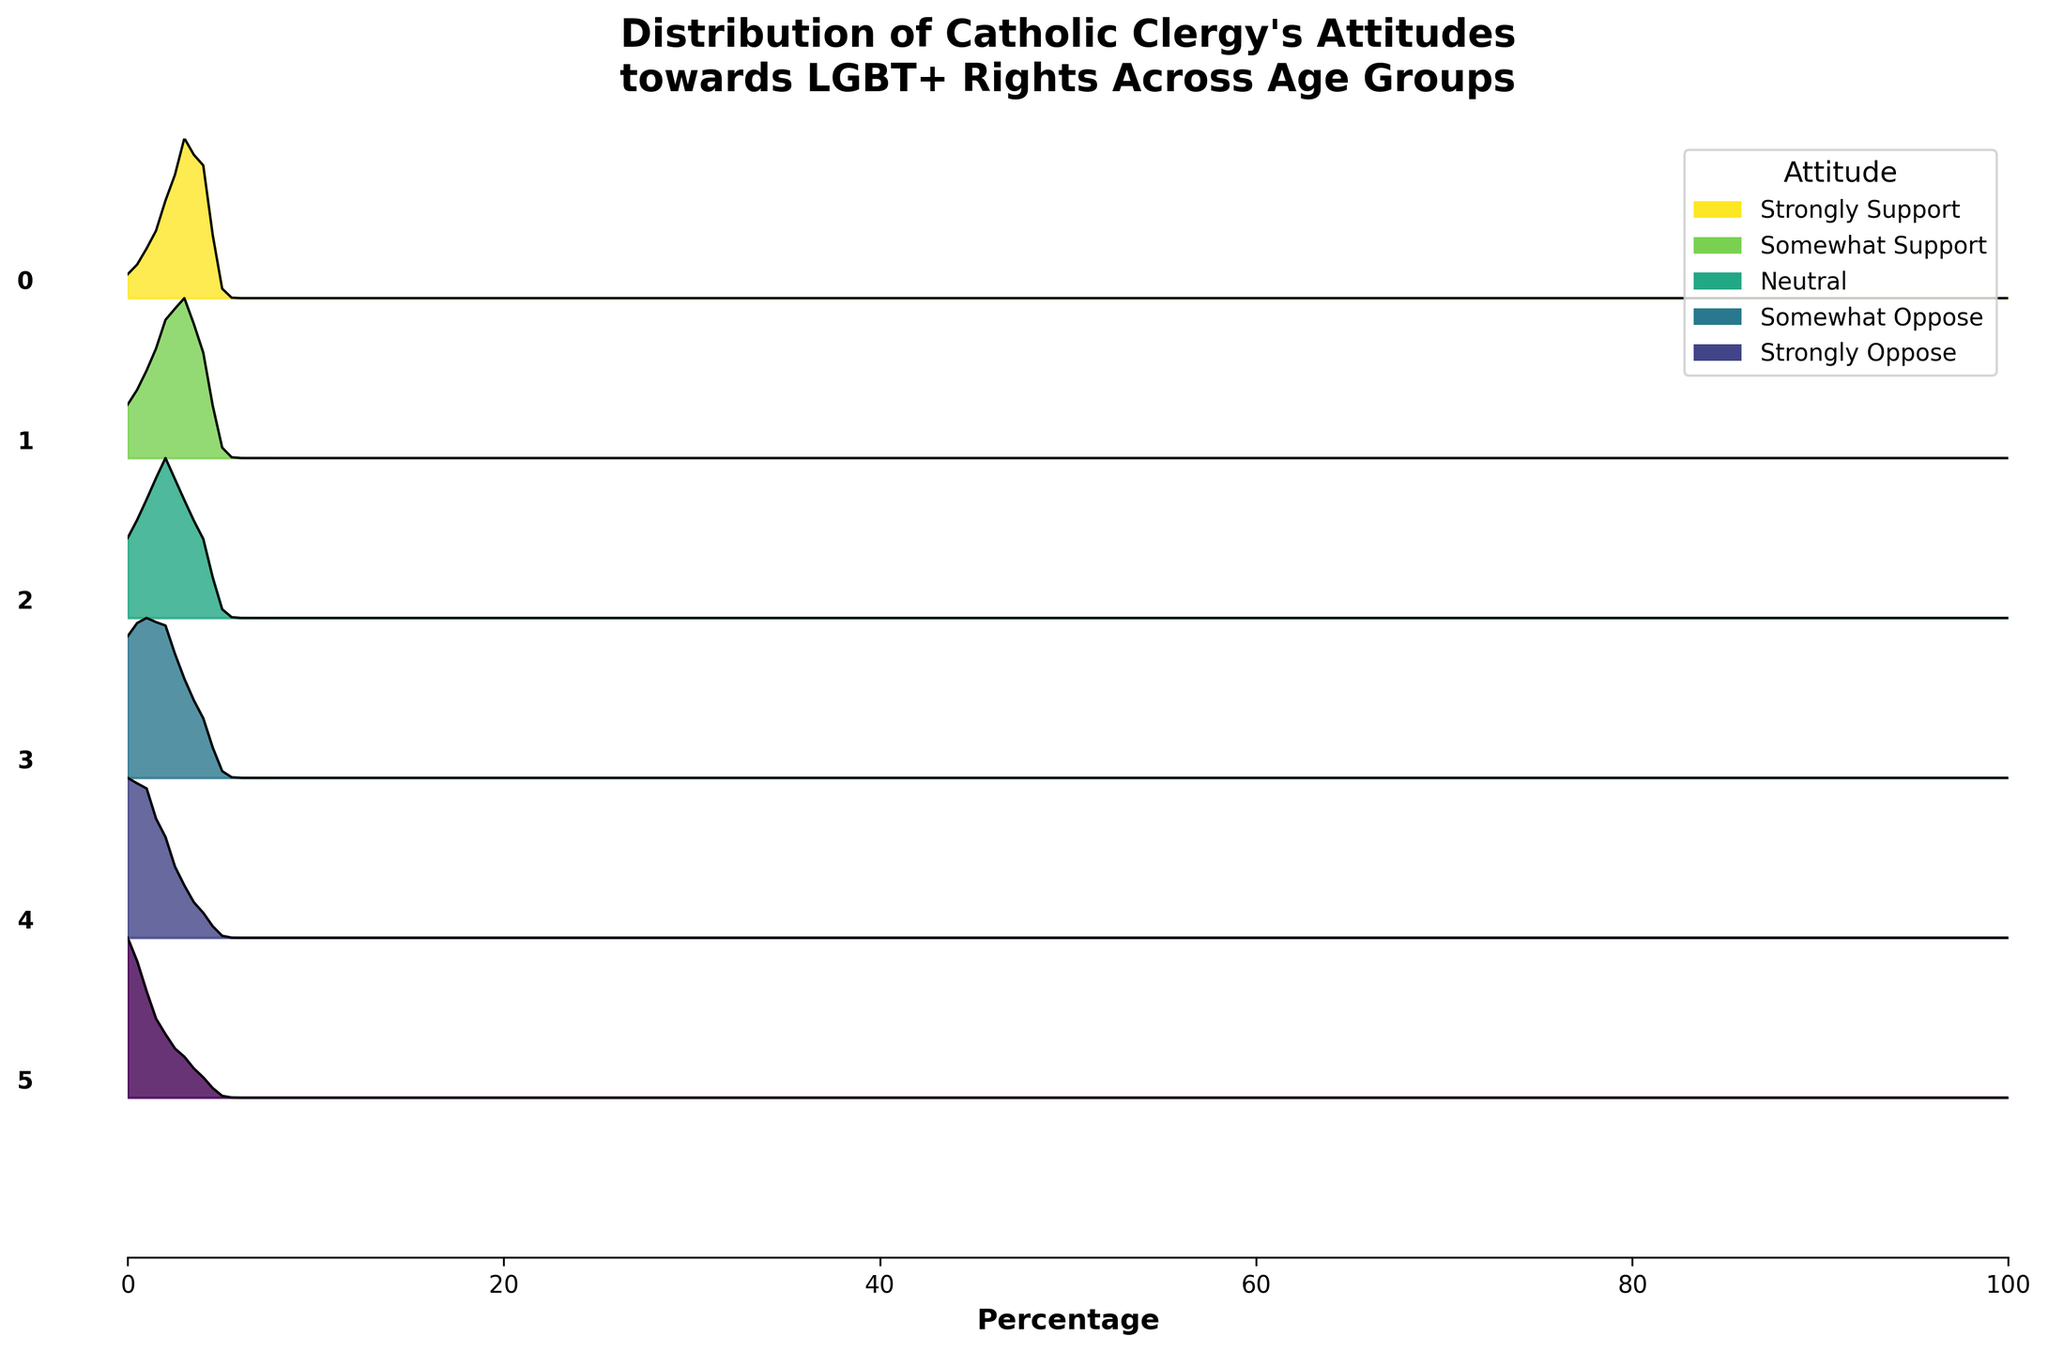Who has the highest percentage of "Strongly Support" attitude? To find the highest percentage of the "Strongly Support" attitude, look for the tallest peak within the "Strongly Support" section, which is represented by the final color gradient, across all age groups.
Answer: 20-30 age group Which age group has the most widespread distribution of attitudes? The most widespread distribution of attitudes would appear as the broadest, most stretched-out plot. Here, the 61-70 age group has the broadest distribution, as seen by the width and spread of its ridgeline.
Answer: 61-70 age group What is the central tendency of attitudes for the 31-40 age group? To determine the central tendency, observe where the peak or highest points of the ridgeline plot for the 31-40 age group are located. The peaks signify the most common attitudes, and for this age group, peaks are around the "Somewhat Support" and "Neutral" sections.
Answer: Somewhat Support to Neutral Which age group shows the highest opposition to LGBT+ rights? The highest opposition is represented by the highest ridgeline peaks in the "Strongly Oppose" section, and it is most prominent in the 71+ age group.
Answer: 71+ age group Compare the "Neutral" attitudes of the 51-60 and 71+ age groups. Which group has more "Neutral" attitudes? To compare, look at the height of the ridgeline peaks within the "Neutral" section for both age groups. The 51-60 age group has more "Neutral" attitudes than the 71+ age group.
Answer: 51-60 age group What trend is observed as the age group increases regarding "Strongly Oppose" attitudes? As the age group increases, the "Strongly Oppose" attitudes trend shows a clear increase in peak heights, indicating a higher percentage of strong opposition in older groups.
Answer: Increasing trend How does the distribution of "Somewhat Support" change with age? By observing the heights and widths of the ridgeline plots in the "Somewhat Support" section, it is evident that the percentage decreases as the age group increases. The 20-30 age group has the highest percentage, which progressively declines in older age groups.
Answer: Decreasing trend Which age group has almost equal distribution across all attitudes? Nearly equal distribution across attitudes would show nearly identical heights of ridgelines for each segment. The 51-60 age group demonstrates this characteristic quite well.
Answer: 51-60 age group 